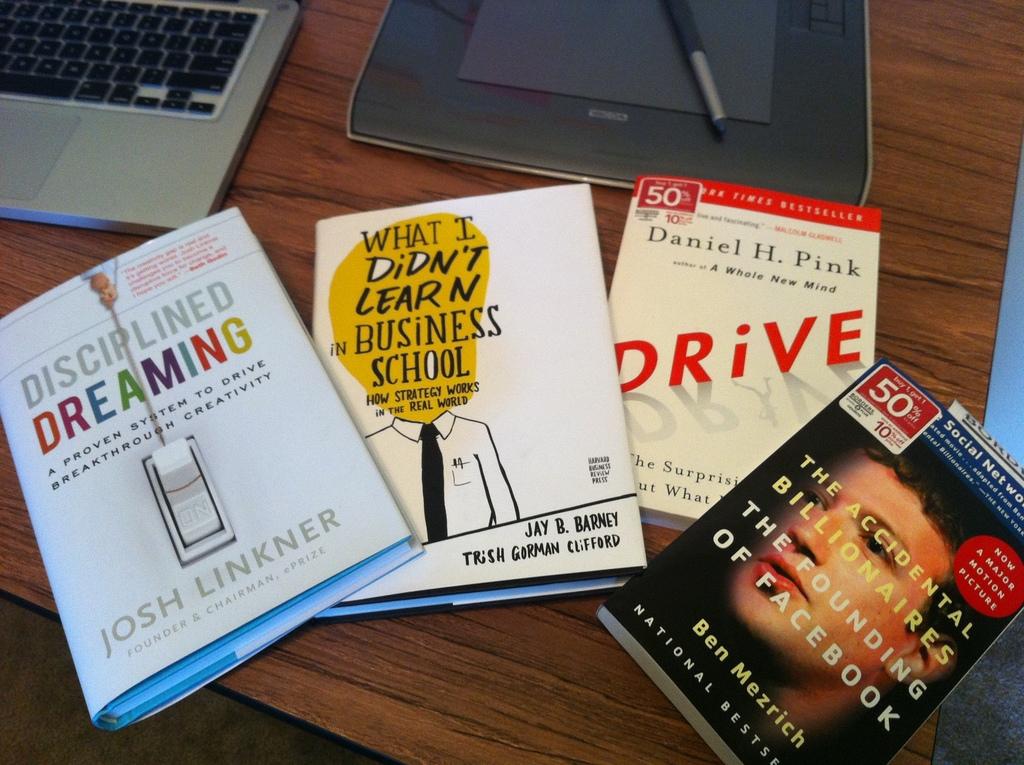What kind of dreaming does the first book talk about?
Your answer should be very brief. Disciplined. Who wrote the first book?
Offer a terse response. Josh linkner. 